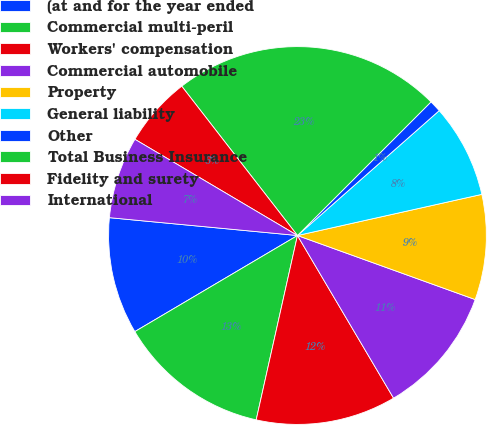Convert chart to OTSL. <chart><loc_0><loc_0><loc_500><loc_500><pie_chart><fcel>(at and for the year ended<fcel>Commercial multi-peril<fcel>Workers' compensation<fcel>Commercial automobile<fcel>Property<fcel>General liability<fcel>Other<fcel>Total Business Insurance<fcel>Fidelity and surety<fcel>International<nl><fcel>10.0%<fcel>13.0%<fcel>12.0%<fcel>11.0%<fcel>9.0%<fcel>8.0%<fcel>1.01%<fcel>22.99%<fcel>6.0%<fcel>7.0%<nl></chart> 